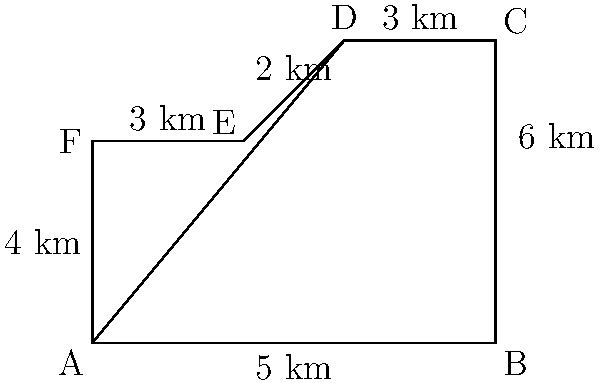The Pakatan Harapan coalition is analyzing a newly proposed constituency boundary. The irregular shape of the constituency can be approximated using geometric shapes as shown in the diagram. Calculate the total area of this constituency in square kilometers. To calculate the area of this irregular shape, we can break it down into simpler geometric shapes:

1. Rectangle ABCF:
   Area = length × width = 8 km × 4 km = 32 km²

2. Right triangle ADF:
   Area = $\frac{1}{2}$ × base × height = $\frac{1}{2}$ × 5 km × 2 km = 5 km²

3. Trapezoid CDEF:
   Area = $\frac{1}{2}$ (parallel side 1 + parallel side 2) × height
        = $\frac{1}{2}$ (3 km + 8 km) × 2 km = 11 km²

Total area:
   = Area of rectangle + Area of triangle + Area of trapezoid
   = 32 km² + 5 km² + 11 km²
   = 48 km²

Therefore, the total area of the constituency is 48 square kilometers.
Answer: 48 km² 